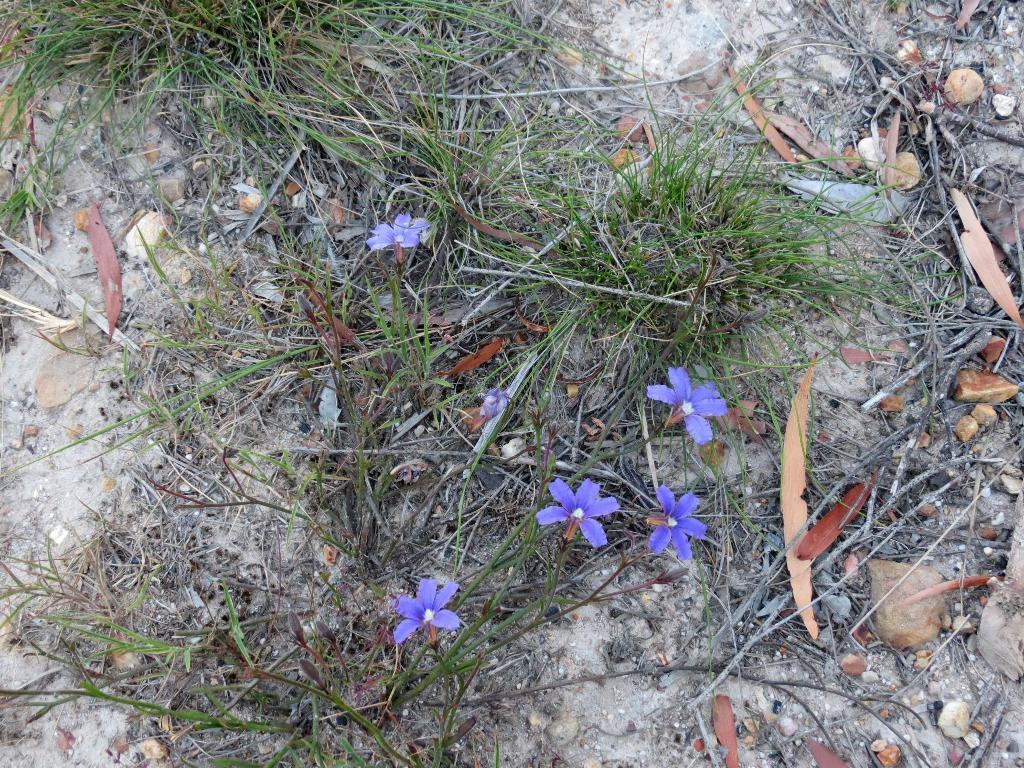What type of flowers can be seen in the image? There are purple color flowers in the image. What type of vegetation is present in the image besides flowers? There is grass in the image. What else can be found on the ground in the image? Dry leaves are present in the image. What type of ring can be seen on the flower in the image? There is no ring present on the flowers in the image. How does the honey look like on the flowers in the image? There is no honey present on the flowers in the image. 